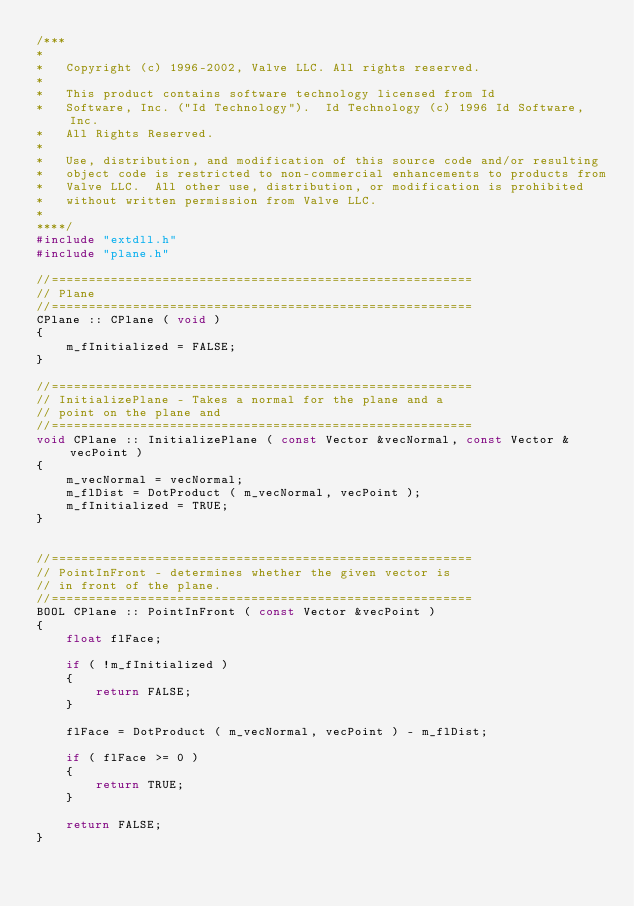<code> <loc_0><loc_0><loc_500><loc_500><_C++_>/***
*
*	Copyright (c) 1996-2002, Valve LLC. All rights reserved.
*	
*	This product contains software technology licensed from Id 
*	Software, Inc. ("Id Technology").  Id Technology (c) 1996 Id Software, Inc. 
*	All Rights Reserved.
*
*   Use, distribution, and modification of this source code and/or resulting
*   object code is restricted to non-commercial enhancements to products from
*   Valve LLC.  All other use, distribution, or modification is prohibited
*   without written permission from Valve LLC.
*
****/
#include "extdll.h"
#include "plane.h"

//=========================================================
// Plane
//=========================================================
CPlane :: CPlane ( void )
{
	m_fInitialized = FALSE;
}

//=========================================================
// InitializePlane - Takes a normal for the plane and a
// point on the plane and 
//=========================================================
void CPlane :: InitializePlane ( const Vector &vecNormal, const Vector &vecPoint )
{
	m_vecNormal = vecNormal;
	m_flDist = DotProduct ( m_vecNormal, vecPoint );
	m_fInitialized = TRUE;
}


//=========================================================
// PointInFront - determines whether the given vector is 
// in front of the plane. 
//=========================================================
BOOL CPlane :: PointInFront ( const Vector &vecPoint )
{
	float flFace;

	if ( !m_fInitialized )
	{
		return FALSE;
	}

	flFace = DotProduct ( m_vecNormal, vecPoint ) - m_flDist;

	if ( flFace >= 0 )
	{
		return TRUE;
	}

	return FALSE;
}

</code> 